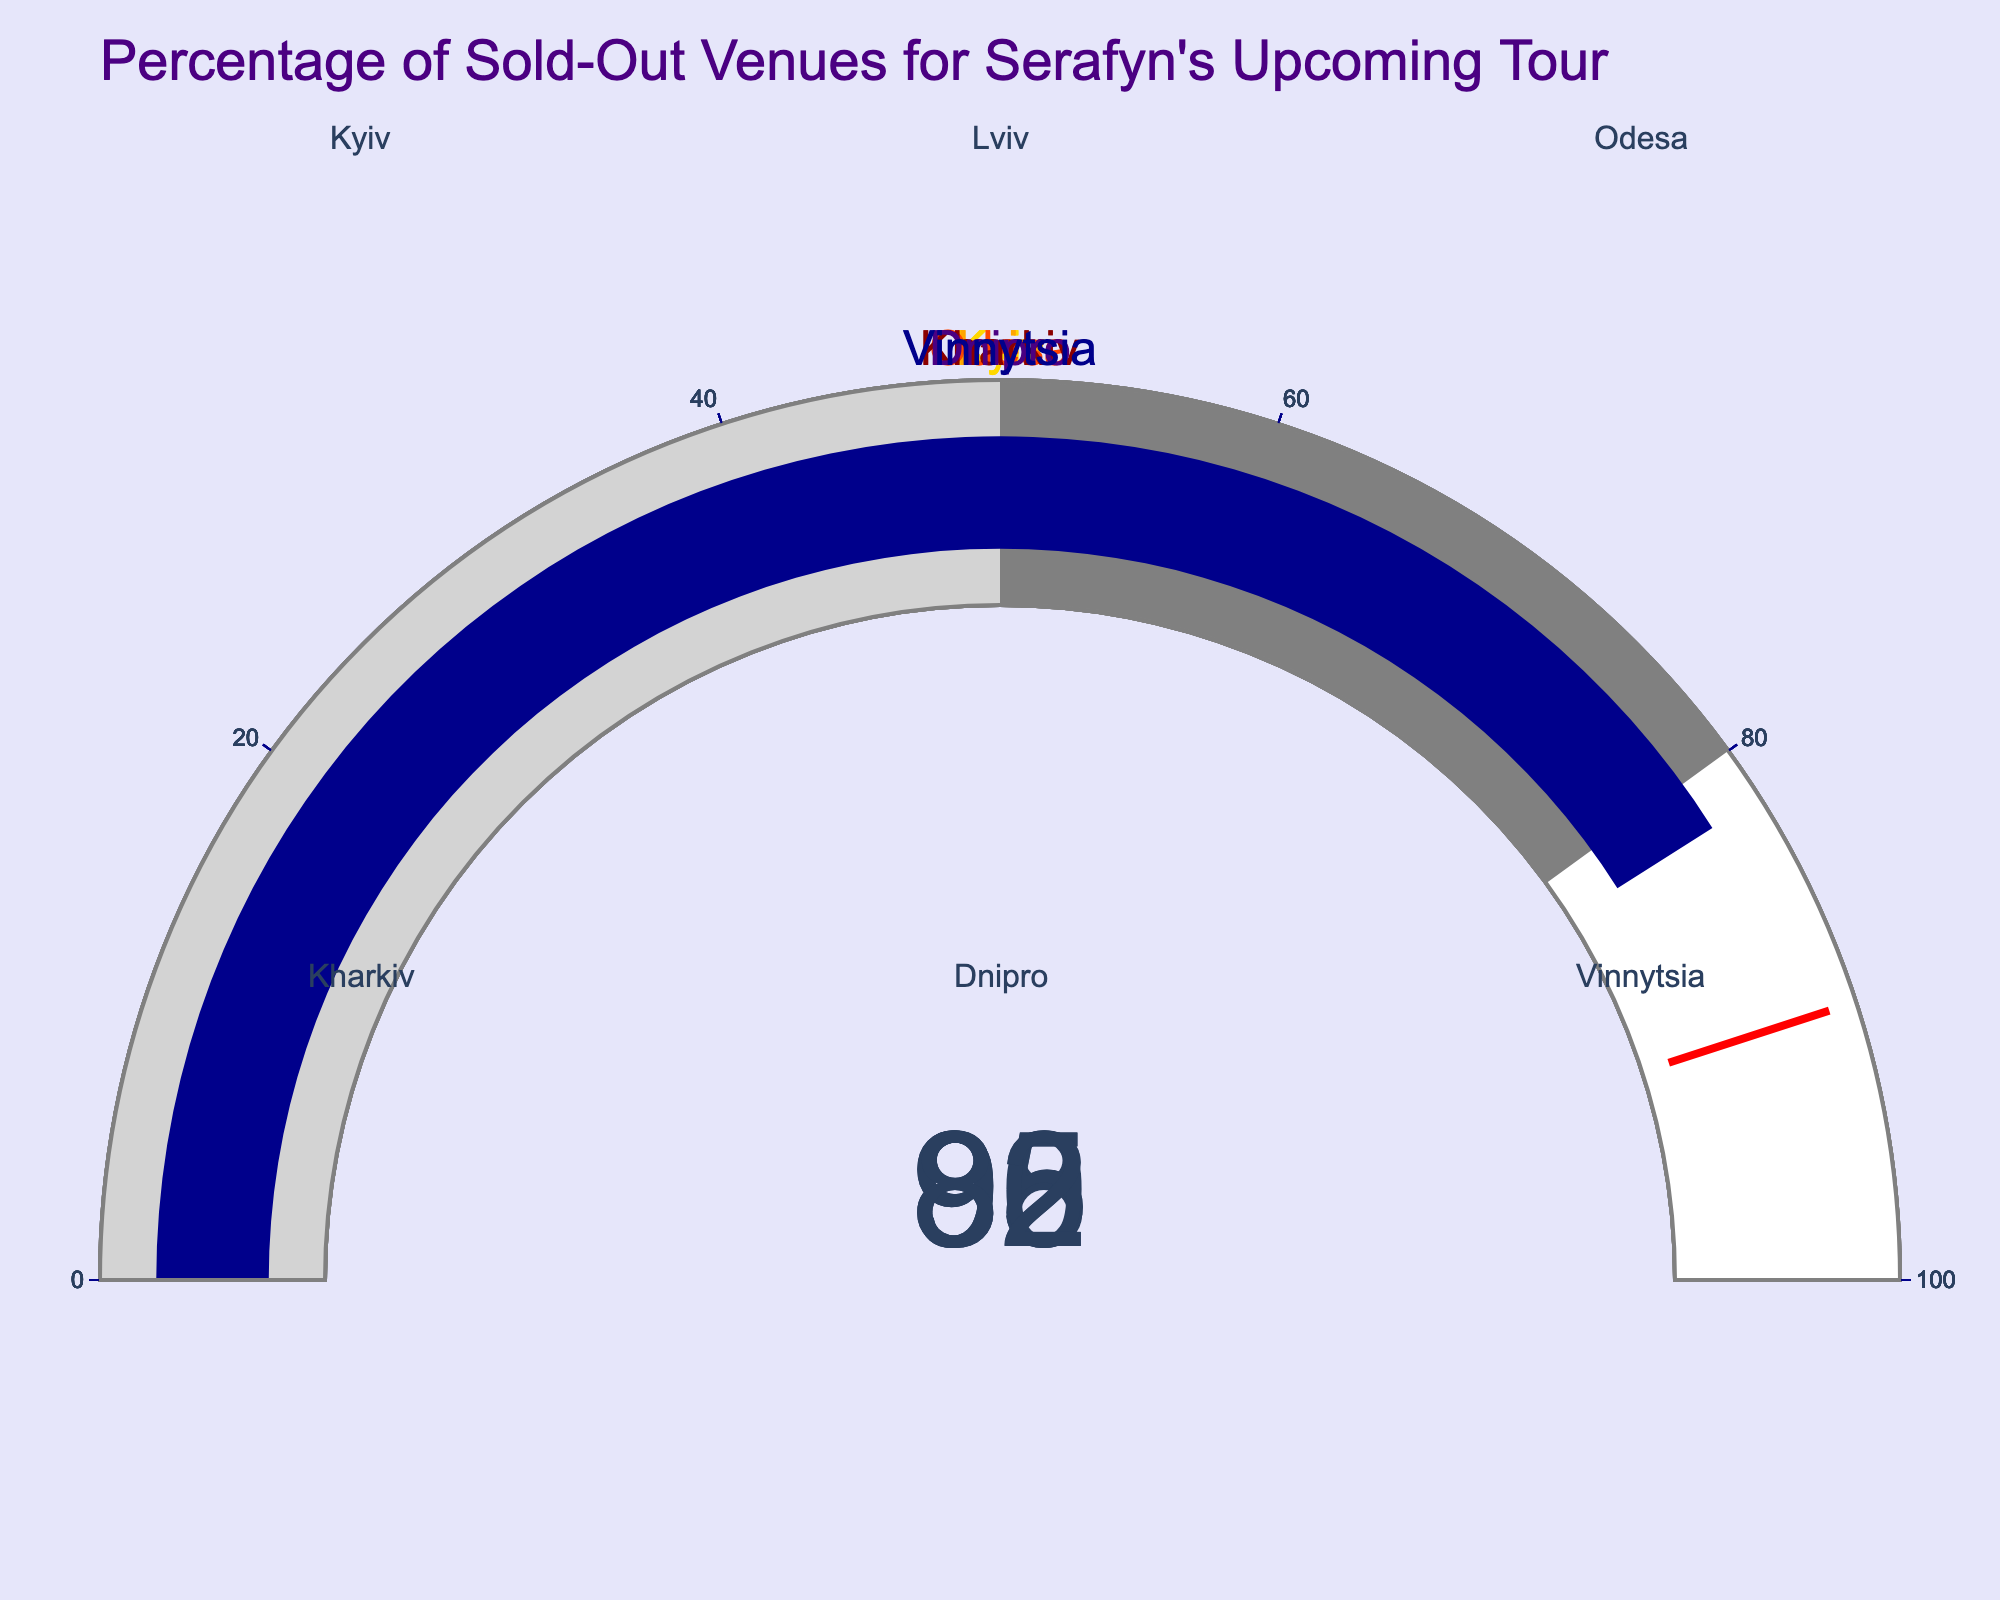Which city has the highest percentage of sold-out venues? Look at the gauges and identify the city with the highest value. Kyiv has a value of 95%, which is the highest among all cities.
Answer: Kyiv What is the total percentage of sold-out venues for Lviv and Odesa combined? Add the percentages for Lviv and Odesa. Lviv has 88% and Odesa has 92%, so 88 + 92 = 180.
Answer: 180% Which city has the lowest percentage of sold-out venues? Look at the gauges and identify the city with the lowest value. Vinnytsia has the lowest percentage at 82%.
Answer: Vinnytsia How many cities have more than 90% of their venues sold out? Count the cities with percentages greater than 90%. Kyiv (95%) and Odesa (92%) both meet this criterion, so the answer is 2.
Answer: 2 What is the average percentage of sold-out venues across all cities? Add all percentages and divide by the number of cities. (95 + 88 + 92 + 85 + 90 + 82) / 6 = 88.67.
Answer: 88.67% Is the percentage of sold-out venues for Dnipro greater than the percentage for Kharkiv? Compare the values for Dnipro (90%) and Kharkiv (85%). Since 90% is greater than 85%, the answer is yes.
Answer: Yes What is the difference in percentages between the city with the highest value and the city with the lowest value? Subtract the percentage of the lowest value (Vinnytsia, 82%) from the highest value (Kyiv, 95%). 95 - 82 = 13.
Answer: 13% How many cities have sold out at least 85% of their venues? Count the cities with percentages of 85% or more. Kyiv (95%), Lviv (88%), Odesa (92%), Kharkiv (85%), and Dnipro (90%) all meet this criterion, so the answer is 5.
Answer: 5 Does Odesa have a higher percentage of sold-out venues than Lviv? Compare the values for Odesa (92%) and Lviv (88%). Since 92% is greater than 88%, the answer is yes.
Answer: Yes 